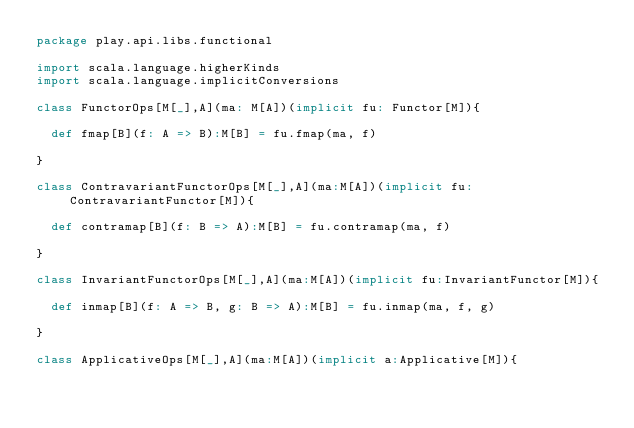Convert code to text. <code><loc_0><loc_0><loc_500><loc_500><_Scala_>package play.api.libs.functional

import scala.language.higherKinds
import scala.language.implicitConversions

class FunctorOps[M[_],A](ma: M[A])(implicit fu: Functor[M]){

  def fmap[B](f: A => B):M[B] = fu.fmap(ma, f)

}

class ContravariantFunctorOps[M[_],A](ma:M[A])(implicit fu:ContravariantFunctor[M]){

  def contramap[B](f: B => A):M[B] = fu.contramap(ma, f)

}

class InvariantFunctorOps[M[_],A](ma:M[A])(implicit fu:InvariantFunctor[M]){

  def inmap[B](f: A => B, g: B => A):M[B] = fu.inmap(ma, f, g)

}

class ApplicativeOps[M[_],A](ma:M[A])(implicit a:Applicative[M]){
</code> 